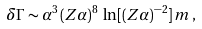<formula> <loc_0><loc_0><loc_500><loc_500>\delta \Gamma \sim \alpha ^ { 3 } \, ( Z \alpha ) ^ { 8 } \, \ln [ ( Z \alpha ) ^ { - 2 } ] \, m \, ,</formula> 